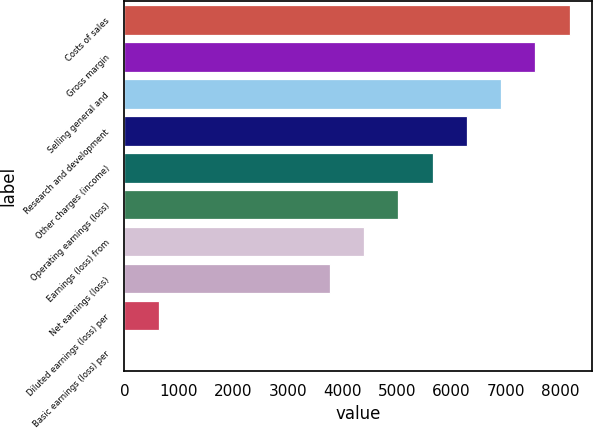<chart> <loc_0><loc_0><loc_500><loc_500><bar_chart><fcel>Costs of sales<fcel>Gross margin<fcel>Selling general and<fcel>Research and development<fcel>Other charges (income)<fcel>Operating earnings (loss)<fcel>Earnings (loss) from<fcel>Net earnings (loss)<fcel>Diluted earnings (loss) per<fcel>Basic earnings (loss) per<nl><fcel>8162.71<fcel>7534.81<fcel>6906.91<fcel>6279.01<fcel>5651.11<fcel>5023.21<fcel>4395.31<fcel>3767.41<fcel>627.91<fcel>0.01<nl></chart> 